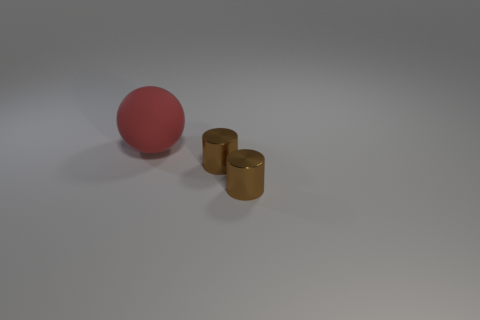Add 1 large red balls. How many objects exist? 4 Subtract all balls. How many objects are left? 2 Add 3 brown things. How many brown things are left? 5 Add 2 shiny cylinders. How many shiny cylinders exist? 4 Subtract 0 cyan cylinders. How many objects are left? 3 Subtract all shiny things. Subtract all big red matte things. How many objects are left? 0 